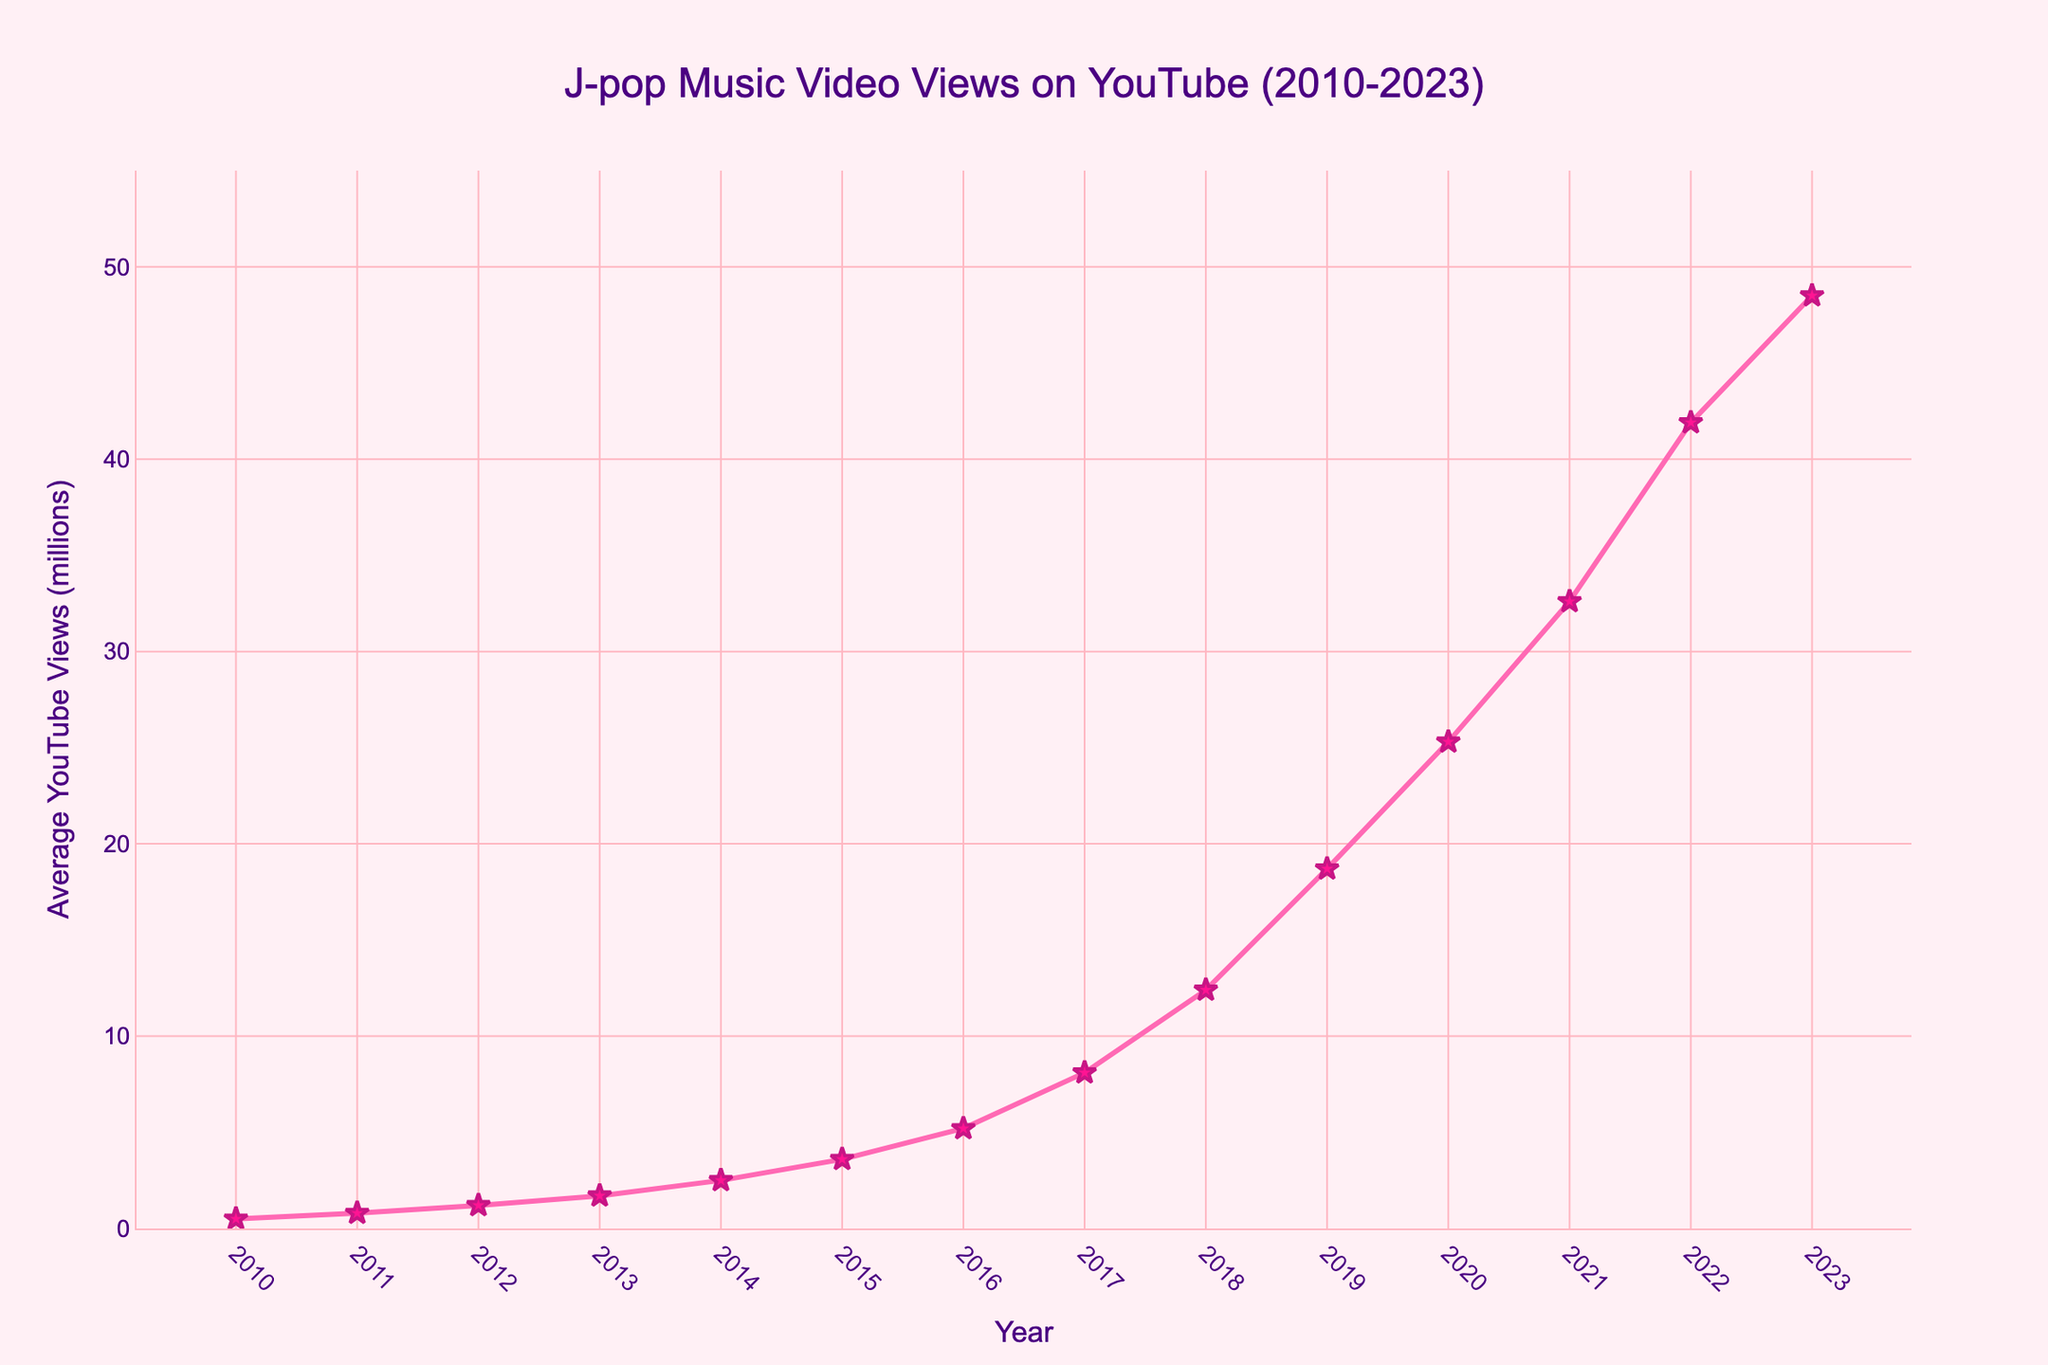What year had the highest average YouTube views for J-pop music videos? The year with the highest point on the chart represents the peak value. In this case, 2023 has the highest average views.
Answer: 2023 How many years did it take for the average views to increase from 1 million to 10 million? Start at the year when the average views first surpass 1 million (2012) and count the years until it surpasses 10 million (2018). From 2012 to 2018, it takes 6 years.
Answer: 6 years Which year showed the largest increase in average YouTube views compared to the previous year? Identify the year with the steepest slope between the consecutive data points. Calculate the differences year by year and compare. The largest increase is from 2018 to 2019 (12.4 to 18.7 million, an increase of 6.3 million).
Answer: 2019 What is the total sum of average YouTube views from 2010 to 2015? Sum the values from 2010 to 2015: 0.5 + 0.8 + 1.2 + 1.7 + 2.5 + 3.6 = 10.3 million.
Answer: 10.3 million How much did the average views increase from 2014 to 2017? Subtract the average views in 2014 from the views in 2017: 8.1 - 2.5 = 5.6 million.
Answer: 5.6 million What is the average annual growth in views from 2010 to 2023? Calculate the difference in views from 2010 to 2023 and divide by the number of years: (48.5 - 0.5) / (2023 - 2010) = 48 / 13 ≈ 3.69 million per year.
Answer: 3.69 million per year What was the trend in average views between 2010 and 2023? The chart shows a continuous upward trend from 2010 to 2023, indicating a consistent increase in average YouTube views for J-pop music videos.
Answer: Increasing How does the average view count in 2022 compare to that in 2010? Find the difference by subtracting the 2010 value from the 2022 value: 41.9 - 0.5 = 41.4 million.
Answer: 41.4 million What is the average view count for the years 2015 to 2020? Sum the values from 2015 to 2020 and divide by the number of years: (3.6 + 5.2 + 8.1 + 12.4 + 18.7 + 25.3) / 6 = 73.3 / 6 ≈ 12.22 million.
Answer: 12.22 million From when did the average view count exceed 20 million? Identify the first year when the average view count is greater than 20 million, which is 2020.
Answer: 2020 